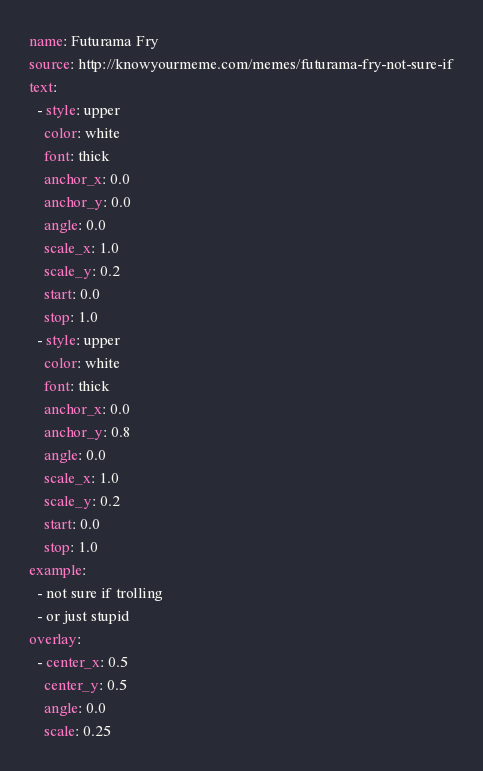<code> <loc_0><loc_0><loc_500><loc_500><_YAML_>name: Futurama Fry
source: http://knowyourmeme.com/memes/futurama-fry-not-sure-if
text:
  - style: upper
    color: white
    font: thick
    anchor_x: 0.0
    anchor_y: 0.0
    angle: 0.0
    scale_x: 1.0
    scale_y: 0.2
    start: 0.0
    stop: 1.0
  - style: upper
    color: white
    font: thick
    anchor_x: 0.0
    anchor_y: 0.8
    angle: 0.0
    scale_x: 1.0
    scale_y: 0.2
    start: 0.0
    stop: 1.0
example:
  - not sure if trolling
  - or just stupid
overlay:
  - center_x: 0.5
    center_y: 0.5
    angle: 0.0
    scale: 0.25
</code> 